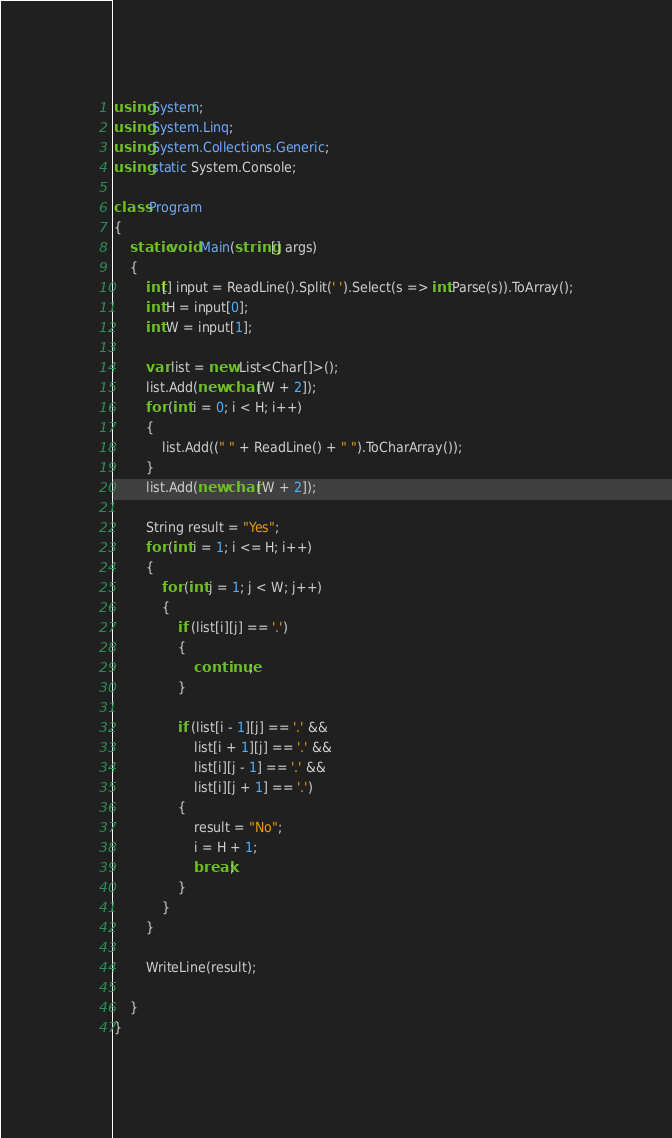Convert code to text. <code><loc_0><loc_0><loc_500><loc_500><_C#_>using System;
using System.Linq;
using System.Collections.Generic;
using static System.Console;

class Program
{
    static void Main(string[] args)
    {
        int[] input = ReadLine().Split(' ').Select(s => int.Parse(s)).ToArray();
        int H = input[0];
        int W = input[1];

        var list = new List<Char[]>();
        list.Add(new char[W + 2]);
        for (int i = 0; i < H; i++)
        {
            list.Add((" " + ReadLine() + " ").ToCharArray());
        }
        list.Add(new char[W + 2]);

        String result = "Yes";
        for (int i = 1; i <= H; i++)
        {
            for (int j = 1; j < W; j++)
            {
                if (list[i][j] == '.')
                {
                    continue;
                }

                if (list[i - 1][j] == '.' &&
                    list[i + 1][j] == '.' &&
                    list[i][j - 1] == '.' &&
                    list[i][j + 1] == '.')
                {
                    result = "No";
                    i = H + 1;
                    break;
                }
            }
        }

        WriteLine(result);

    }
}</code> 